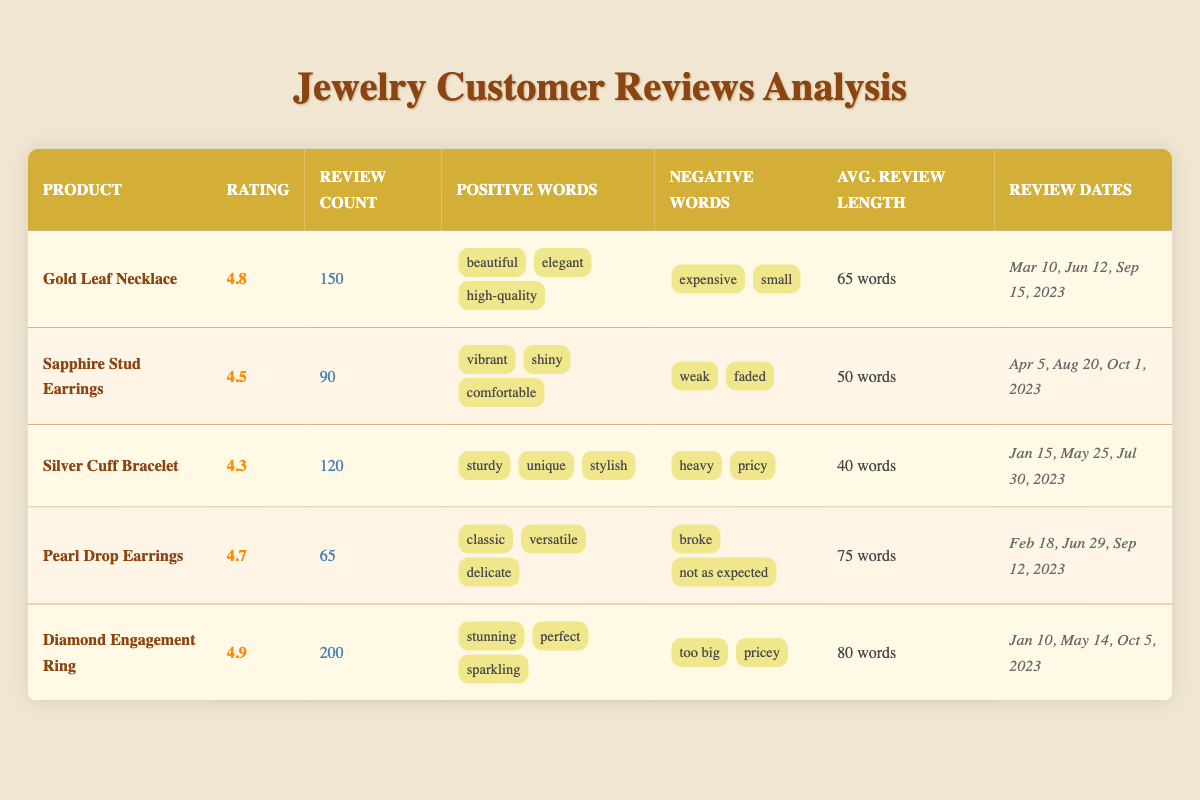What is the highest-rated jewelry product? The table shows the ratings for all products. The highest rating is 4.9 for the "Diamond Engagement Ring."
Answer: Diamond Engagement Ring How many reviews did the "Gold Leaf Necklace" receive? The "Gold Leaf Necklace" has a review count of 150 listed in the respective row.
Answer: 150 What are the most common positive words for "Sapphire Stud Earrings"? The most common positive words for "Sapphire Stud Earrings" are listed as vibrant, shiny, and comfortable in that row.
Answer: vibrant, shiny, comfortable Which product has the lowest average review length? By comparing the average review lengths, "Silver Cuff Bracelet" has the lowest at 40 words.
Answer: Silver Cuff Bracelet True or False: The "Pearl Drop Earrings" received more than 80 reviews. The review count for "Pearl Drop Earrings" is 65, which is not more than 80, so this statement is false.
Answer: False What is the average rating of all listed jewelry products? To find the average rating, sum the ratings (4.8 + 4.5 + 4.3 + 4.7 + 4.9 = 24.2) and divide by the number of products (5). The average rating is 24.2 / 5 = 4.84.
Answer: 4.84 Which product has the most review dates listed? The "Diamond Engagement Ring" has three review dates listed: Jan 10, May 14, and Oct 5, 2023. No other product has more review dates.
Answer: Diamond Engagement Ring What is the percentage of positive words that mention "delicate," and how does it compare to "sturdy"? "Delicate" is in the positive words of "Pearl Drop Earrings," while "sturdy" is mentioned for "Silver Cuff Bracelet." Each appears once in their respective products. Hence, both have a percentage of 1 out of the total counts of positive words across all products (which is 15) or about 6.67%.
Answer: Both are about 6.67% What is the difference in review counts between the "Diamond Engagement Ring" and "Sapphire Stud Earrings"? The review count for the "Diamond Engagement Ring" is 200, and for the "Sapphire Stud Earrings," it is 90. The difference is 200 - 90 = 110.
Answer: 110 